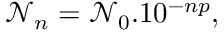<formula> <loc_0><loc_0><loc_500><loc_500>\ m a t h s c r { N } _ { n } = \ m a t h s c r { N } _ { 0 } . 1 0 ^ { - n p } ,</formula> 